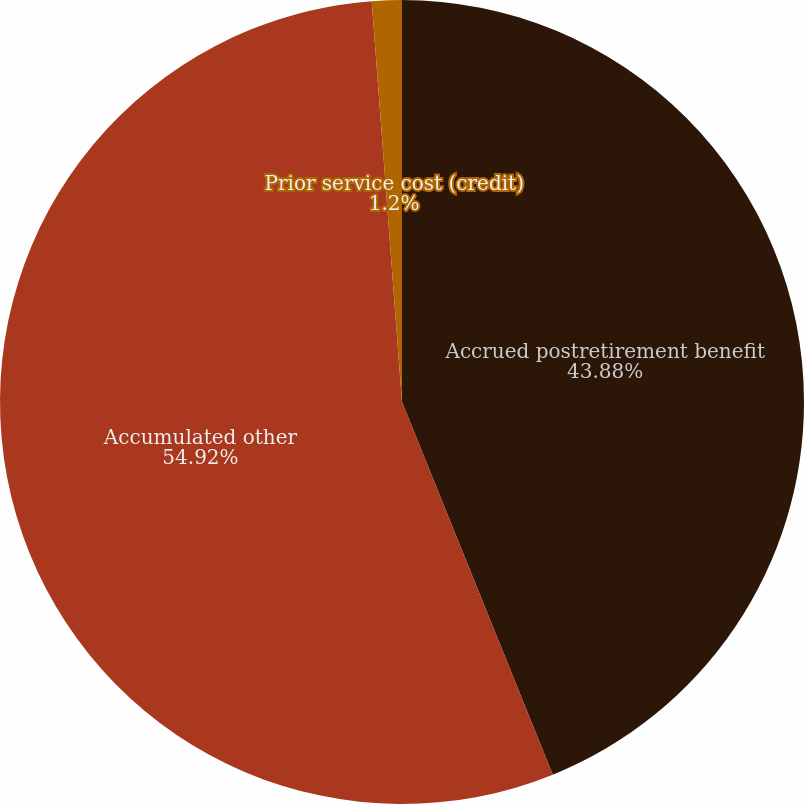<chart> <loc_0><loc_0><loc_500><loc_500><pie_chart><fcel>Accrued postretirement benefit<fcel>Accumulated other<fcel>Prior service cost (credit)<nl><fcel>43.88%<fcel>54.92%<fcel>1.2%<nl></chart> 